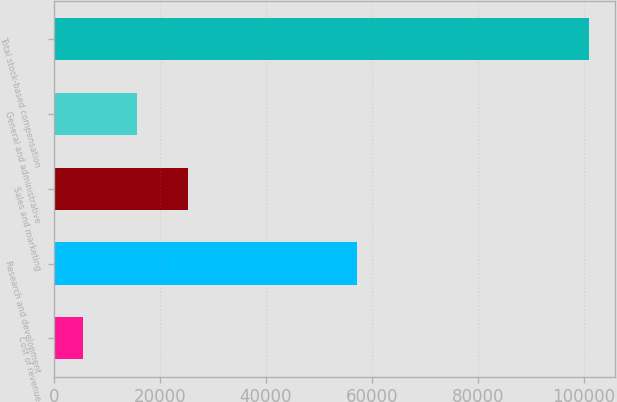Convert chart to OTSL. <chart><loc_0><loc_0><loc_500><loc_500><bar_chart><fcel>Cost of revenue<fcel>Research and development<fcel>Sales and marketing<fcel>General and administrative<fcel>Total stock-based compensation<nl><fcel>5625<fcel>57174<fcel>25260.4<fcel>15727<fcel>100959<nl></chart> 